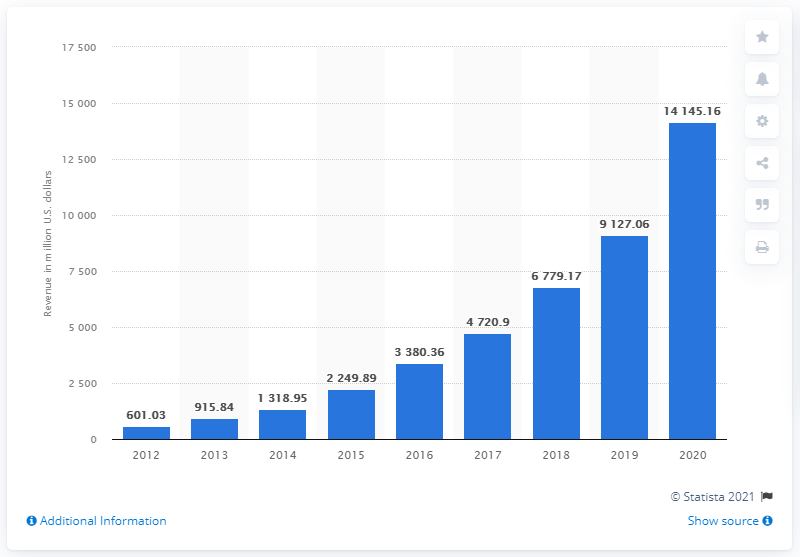List a handful of essential elements in this visual. Wayfair generated approximately $141,451.60 in revenue in 2020. In the prior year, Wayfair generated a total revenue of $91,27.06. 